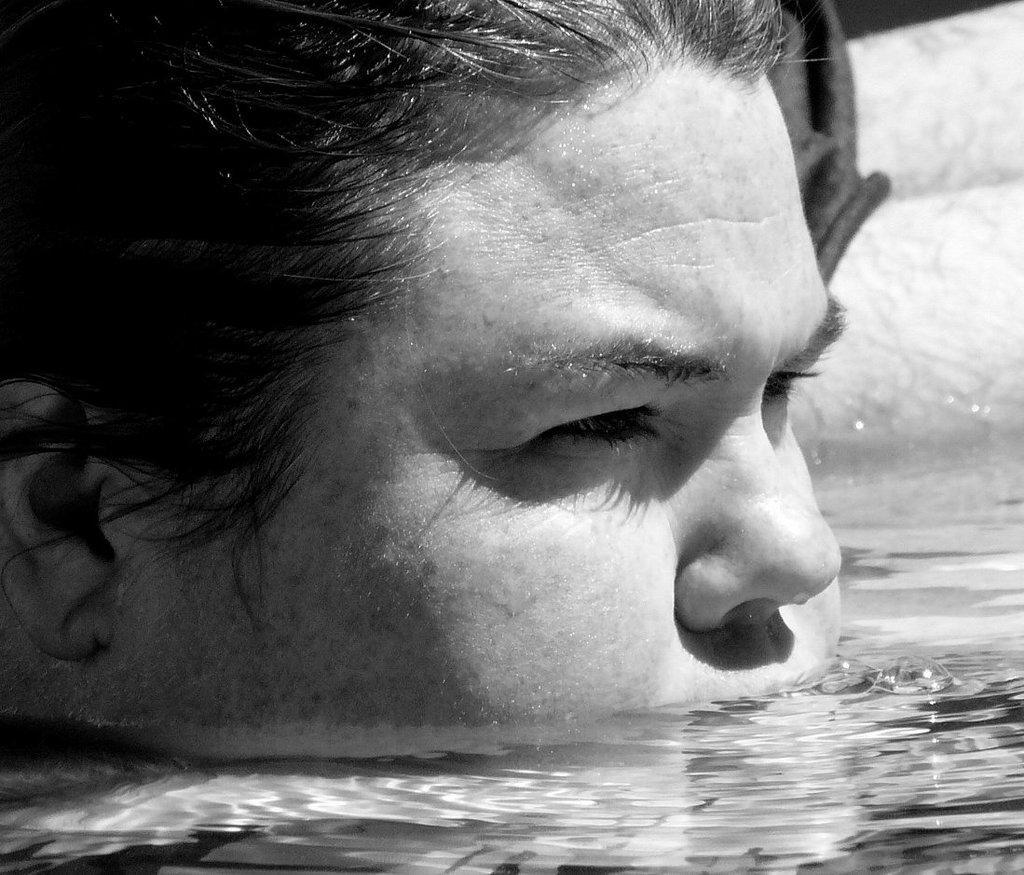Can you describe this image briefly? As we can see in the image there is water and human face. In the background there is a white color wall. 